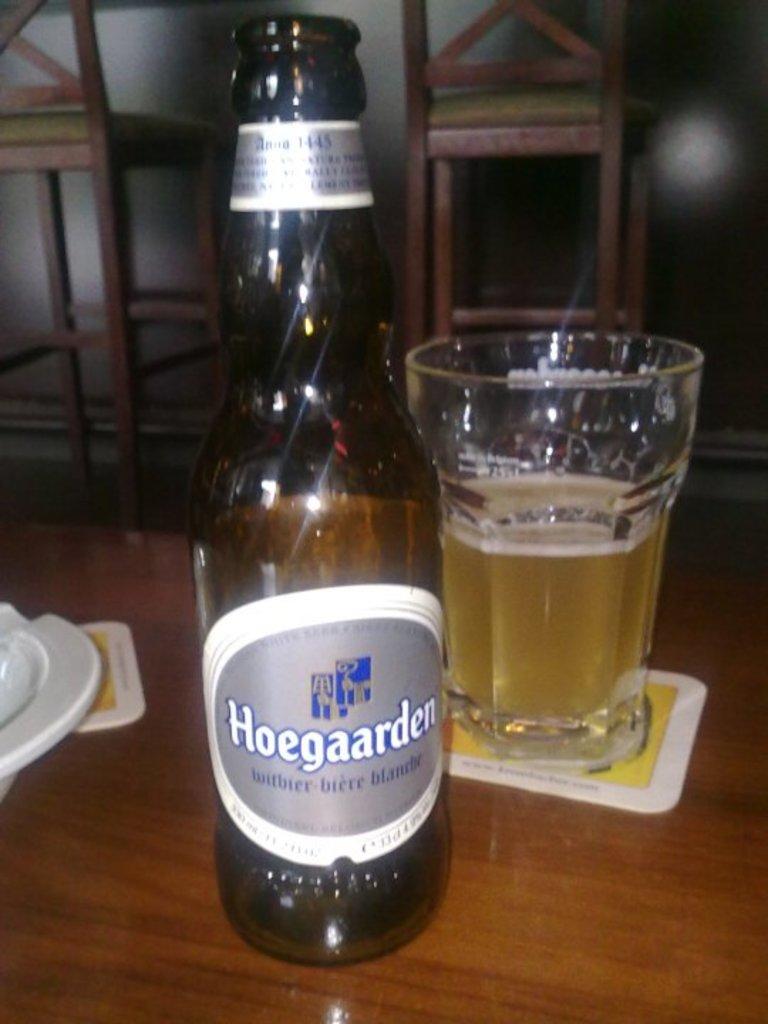What is the name of the beer?
Your response must be concise. Hoegaarden. 